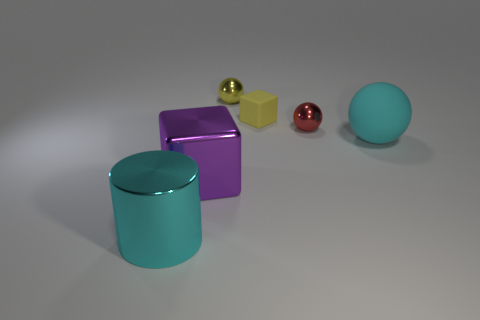Add 1 big purple metal blocks. How many objects exist? 7 Subtract all cylinders. How many objects are left? 5 Add 6 shiny spheres. How many shiny spheres are left? 8 Add 5 red metallic blocks. How many red metallic blocks exist? 5 Subtract 0 red cylinders. How many objects are left? 6 Subtract all large shiny things. Subtract all yellow metal objects. How many objects are left? 3 